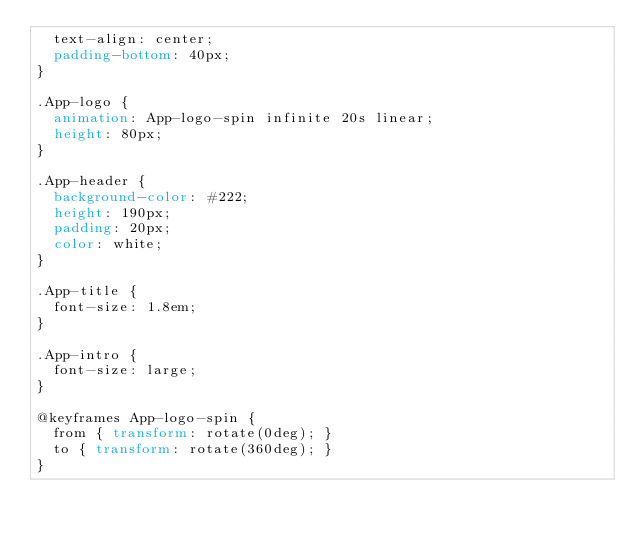Convert code to text. <code><loc_0><loc_0><loc_500><loc_500><_CSS_>  text-align: center;
  padding-bottom: 40px;
}

.App-logo {
  animation: App-logo-spin infinite 20s linear;
  height: 80px;
}

.App-header {
  background-color: #222;
  height: 190px;
  padding: 20px;
  color: white;
}

.App-title {
  font-size: 1.8em;
}

.App-intro {
  font-size: large;
}

@keyframes App-logo-spin {
  from { transform: rotate(0deg); }
  to { transform: rotate(360deg); }
}
</code> 